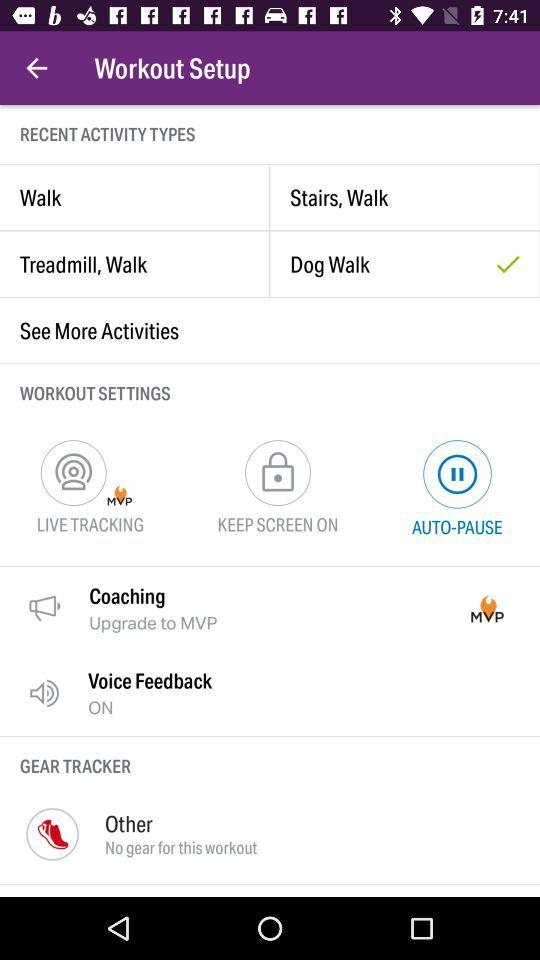What is the selected recent activity type? The selected recent activity type is "Dog Walk". 